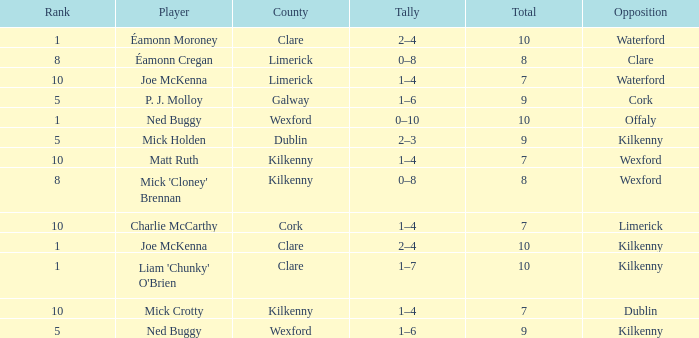What is galway county's total? 9.0. 